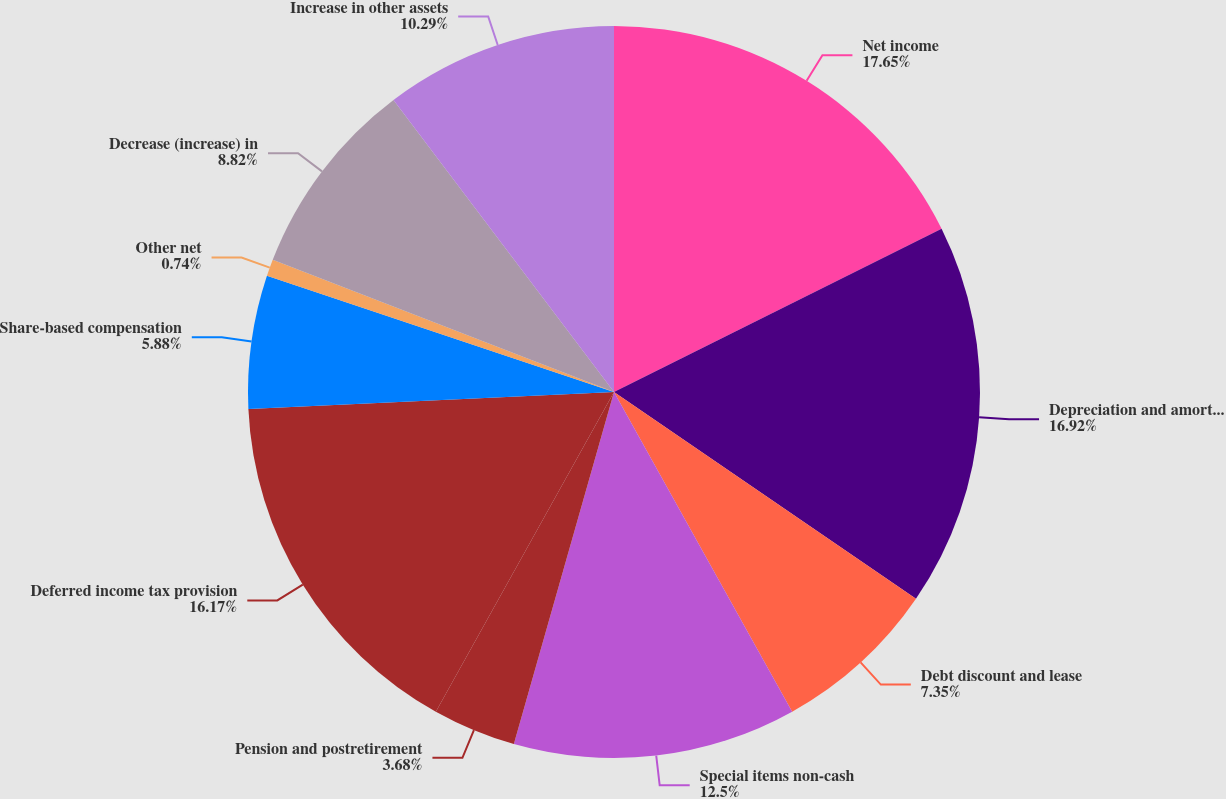Convert chart. <chart><loc_0><loc_0><loc_500><loc_500><pie_chart><fcel>Net income<fcel>Depreciation and amortization<fcel>Debt discount and lease<fcel>Special items non-cash<fcel>Pension and postretirement<fcel>Deferred income tax provision<fcel>Share-based compensation<fcel>Other net<fcel>Decrease (increase) in<fcel>Increase in other assets<nl><fcel>17.64%<fcel>16.91%<fcel>7.35%<fcel>12.5%<fcel>3.68%<fcel>16.17%<fcel>5.88%<fcel>0.74%<fcel>8.82%<fcel>10.29%<nl></chart> 